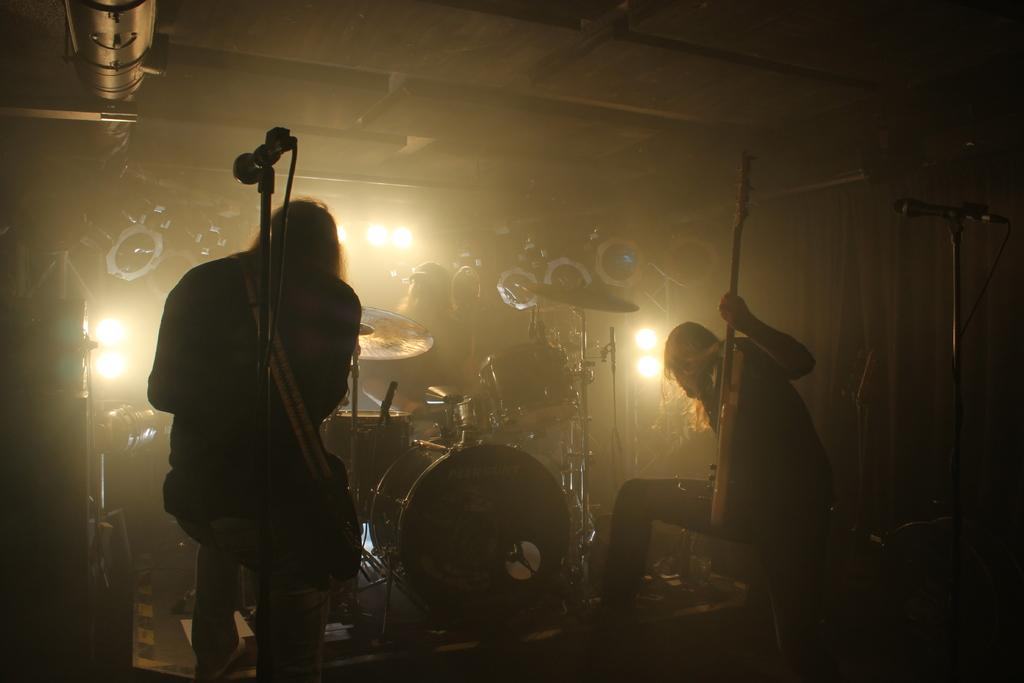What are the people in the image doing? The people in the image are playing musical instruments. What other creatures are present in the image besides the people? There are mice in the image. What can be seen in the image that provides illumination? There are lights in the image. What type of coil is being used by the people playing musical instruments in the image? There is no coil visible in the image; the people are simply playing their instruments without any visible coils. 